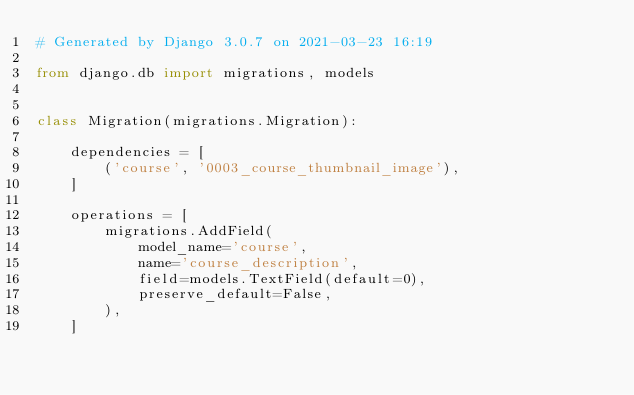<code> <loc_0><loc_0><loc_500><loc_500><_Python_># Generated by Django 3.0.7 on 2021-03-23 16:19

from django.db import migrations, models


class Migration(migrations.Migration):

    dependencies = [
        ('course', '0003_course_thumbnail_image'),
    ]

    operations = [
        migrations.AddField(
            model_name='course',
            name='course_description',
            field=models.TextField(default=0),
            preserve_default=False,
        ),
    ]
</code> 